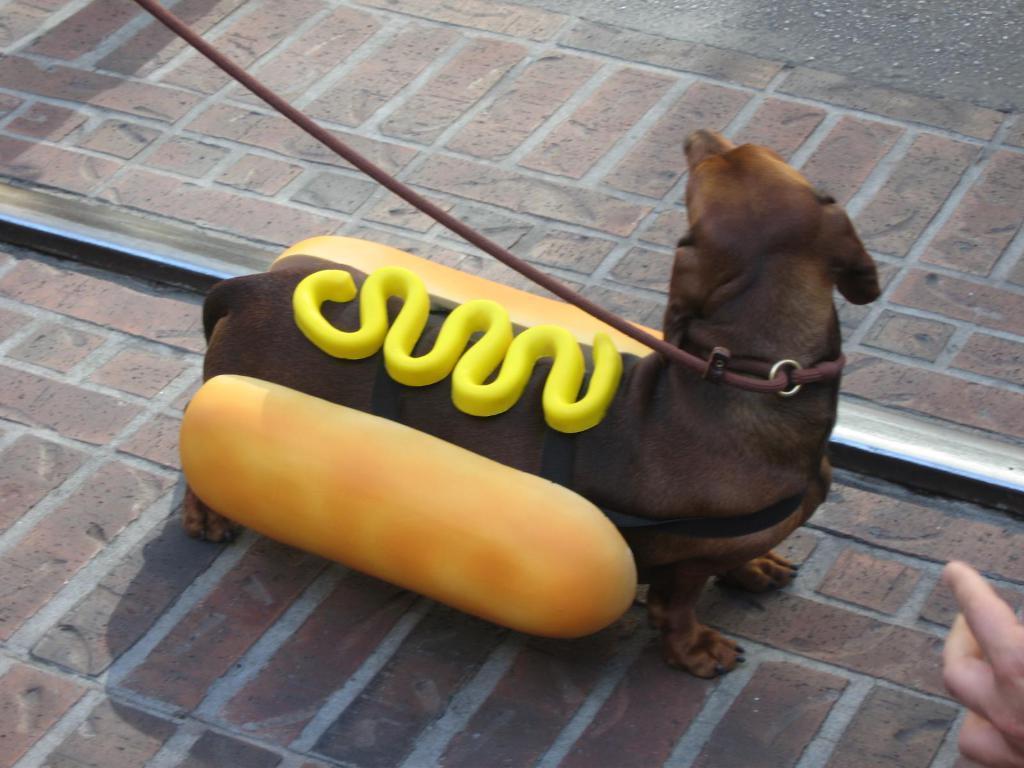Describe this image in one or two sentences. In this picture we observe a brown dog which is dressed as ham burger with cheese on top of it. 